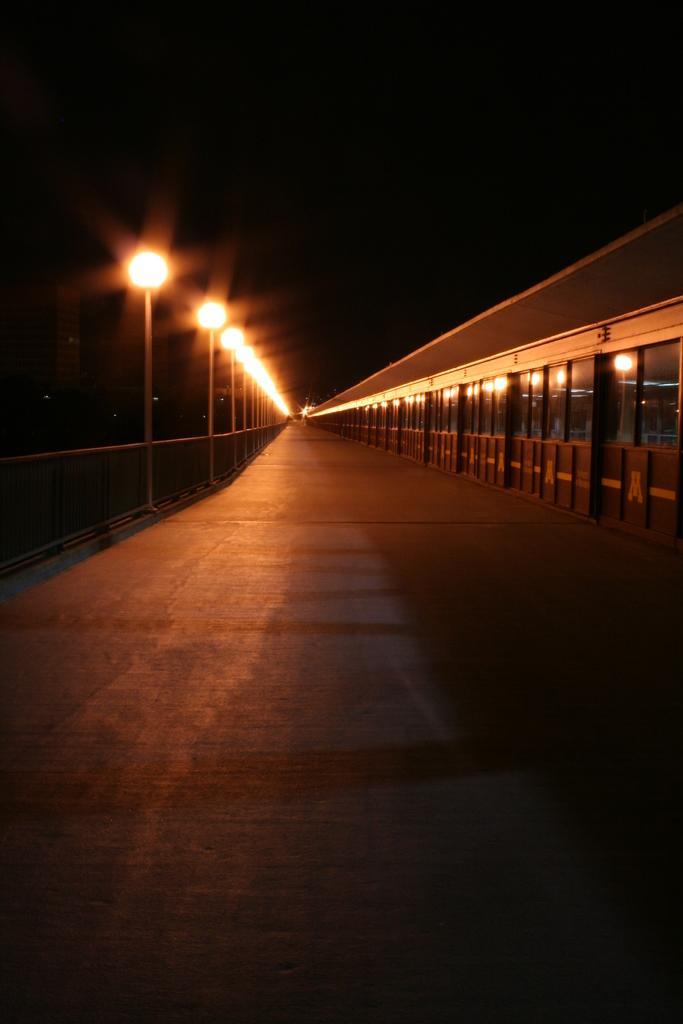Please provide a concise description of this image. In this picture we can observe a road. On the left side there are some poles and lights. We can observe a railing. On the right side there is a building. The background is completely dark. 